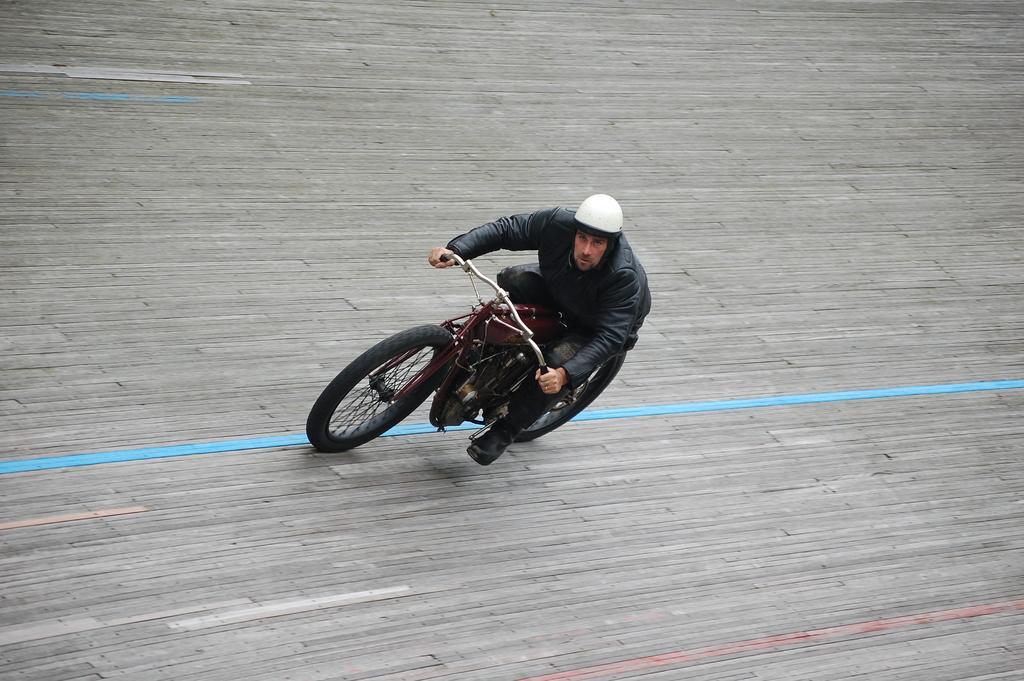In one or two sentences, can you explain what this image depicts? In this image I can see a man is sitting on a vehicle. The man is wearing a jacket and a white color helmet. 